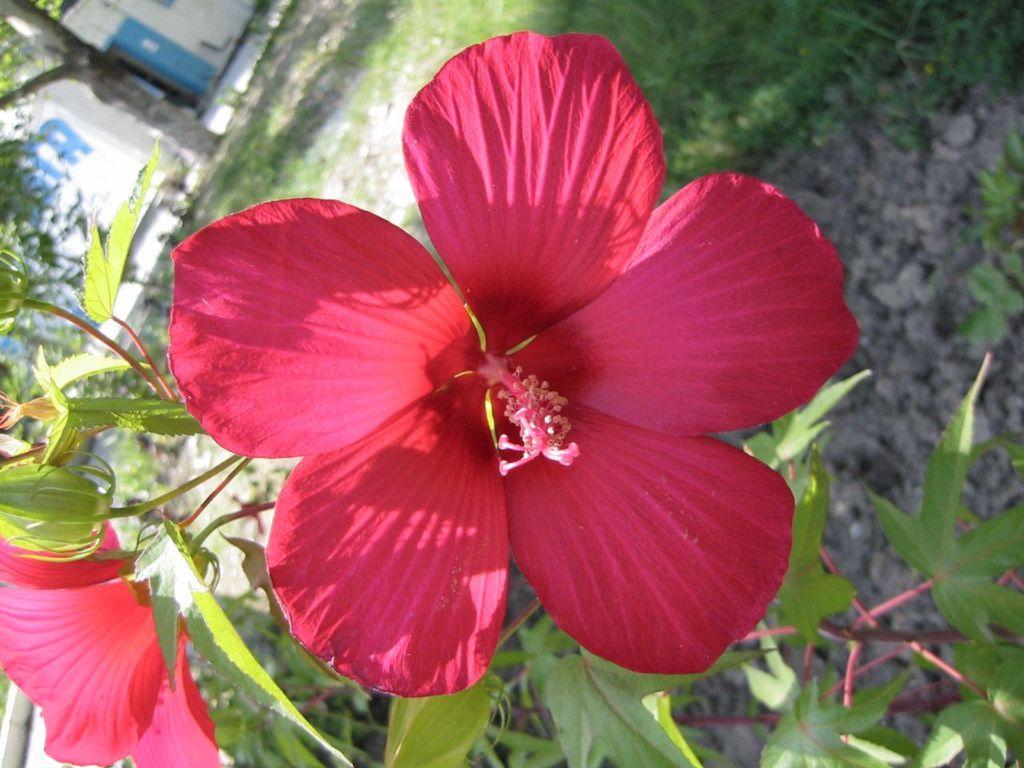Please provide a concise description of this image. There are hibiscus flowers, buds and leaves on a plant. On the ground there is grass. In the background there is a tree and a wall. 